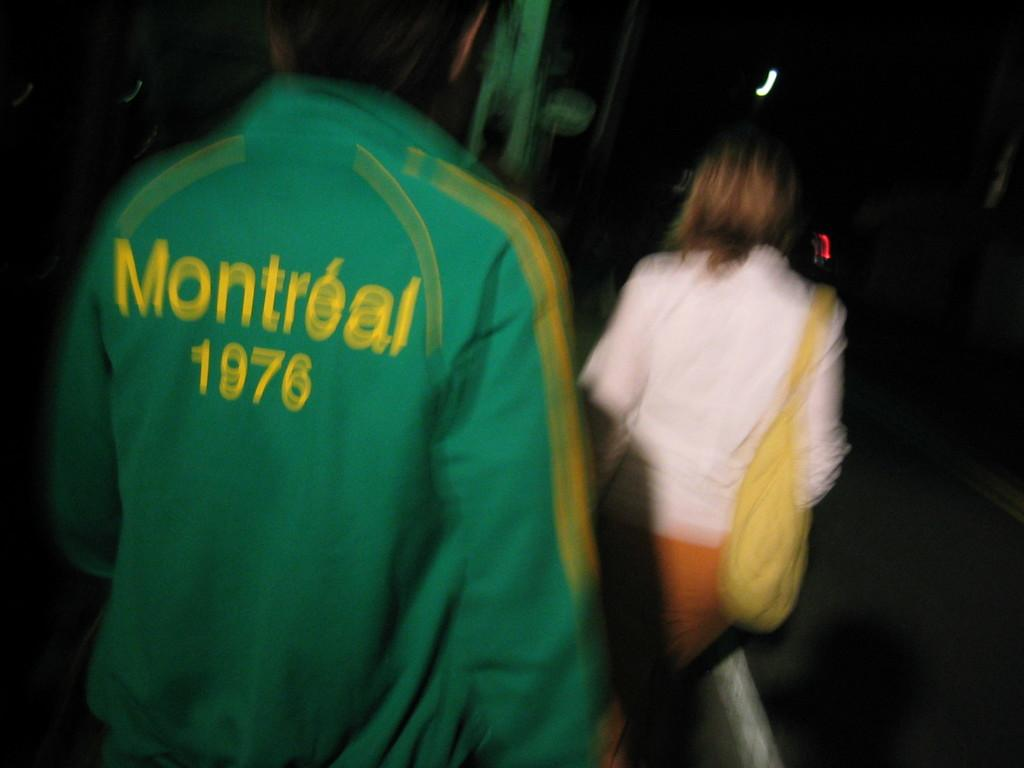<image>
Offer a succinct explanation of the picture presented. The year written on the green top is 1976. 